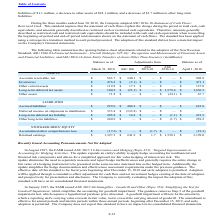According to Microchip Technology's financial document, What was the balance of net accounts receivable on March 31, 2018? According to the financial document, 563.7 (in millions). The relevant text states: "Accounts receivable, net $ 563.7 $ 340.1 $ — $ — $ 903.8..." Also, What was the balance of Inventories on April 1, 2018? According to the financial document, 471.1 (in millions). The relevant text states: "Inventories $ 476.2 $ (5.1) $ — $ — $ 471.1..." Also, What was the adjustment from ASC 606 for other current assets? According to the financial document, 17.2 (in millions). The relevant text states: "Other current assets $ 119.8 $ 17.2 $ — $ — $ 137.0..." Also, How many liabilities had a balance on March 31, 2018 that exceeded $300 million? Based on the analysis, there are 1 instances. The counting process: Deferred income on shipments to distributors. Also, How many Assets had a balance on April 1, 2018 that exceeded $1,000 million? Based on the analysis, there are 1 instances. The counting process: Long-term deferred tax assets. Also, can you calculate: What was the percentage change in Other assets due to the adjustments? To answer this question, I need to perform calculations using the financial data. The calculation is: (47.7-71.8)/71.8, which equals -33.57 (percentage). This is based on the information: "Other assets $ 71.8 $ — $ — $ (24.1) $ 47.7 Other assets $ 71.8 $ — $ — $ (24.1) $ 47.7..." The key data points involved are: 47.7, 71.8. 